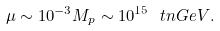Convert formula to latex. <formula><loc_0><loc_0><loc_500><loc_500>\mu \sim 1 0 ^ { - 3 } M _ { p } \sim 1 0 ^ { 1 5 } \ t n { G e V } .</formula> 